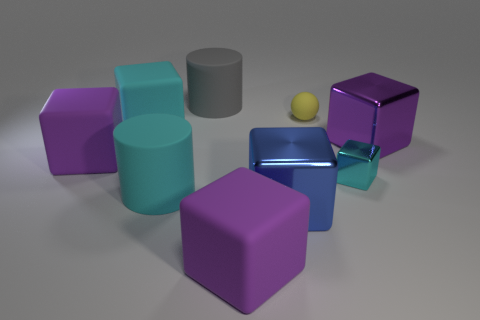Do the yellow matte thing and the cyan metallic cube that is on the right side of the large cyan cylinder have the same size?
Offer a terse response. Yes. Is the number of cyan metal blocks that are behind the big gray matte cylinder less than the number of purple objects that are in front of the big cyan cube?
Your answer should be compact. Yes. There is a cyan cube that is on the left side of the cyan rubber cylinder; what is its size?
Provide a succinct answer. Large. Do the cyan cylinder and the purple metal cube have the same size?
Your answer should be very brief. Yes. What number of things are both in front of the large purple shiny cube and on the left side of the small cyan block?
Your answer should be compact. 4. How many gray things are either small blocks or big matte cylinders?
Provide a short and direct response. 1. What number of shiny objects are gray objects or tiny brown things?
Your response must be concise. 0. Is there a cyan cylinder?
Ensure brevity in your answer.  Yes. Does the gray matte object have the same shape as the small cyan object?
Your answer should be very brief. No. How many big rubber objects are behind the cyan block that is on the left side of the large cyan object that is right of the big cyan matte cube?
Offer a very short reply. 1. 